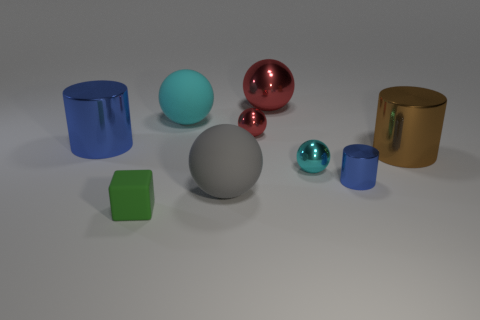There is a red ball that is the same size as the green matte block; what material is it?
Provide a short and direct response. Metal. What number of other objects are there of the same color as the big metallic sphere?
Make the answer very short. 1. Are there any other things that are the same size as the green block?
Offer a very short reply. Yes. There is a blue object on the left side of the green rubber object; does it have the same size as the big red sphere?
Keep it short and to the point. Yes. What material is the cyan ball that is left of the cyan metallic sphere?
Provide a succinct answer. Rubber. Is there any other thing that is the same shape as the gray thing?
Keep it short and to the point. Yes. How many metal objects are either gray things or tiny cubes?
Your response must be concise. 0. Are there fewer cubes that are on the right side of the small blue metallic cylinder than green things?
Your answer should be very brief. Yes. The tiny thing left of the big rubber object in front of the red sphere on the left side of the big metal sphere is what shape?
Provide a succinct answer. Cube. Do the tiny cylinder and the large shiny sphere have the same color?
Provide a succinct answer. No. 